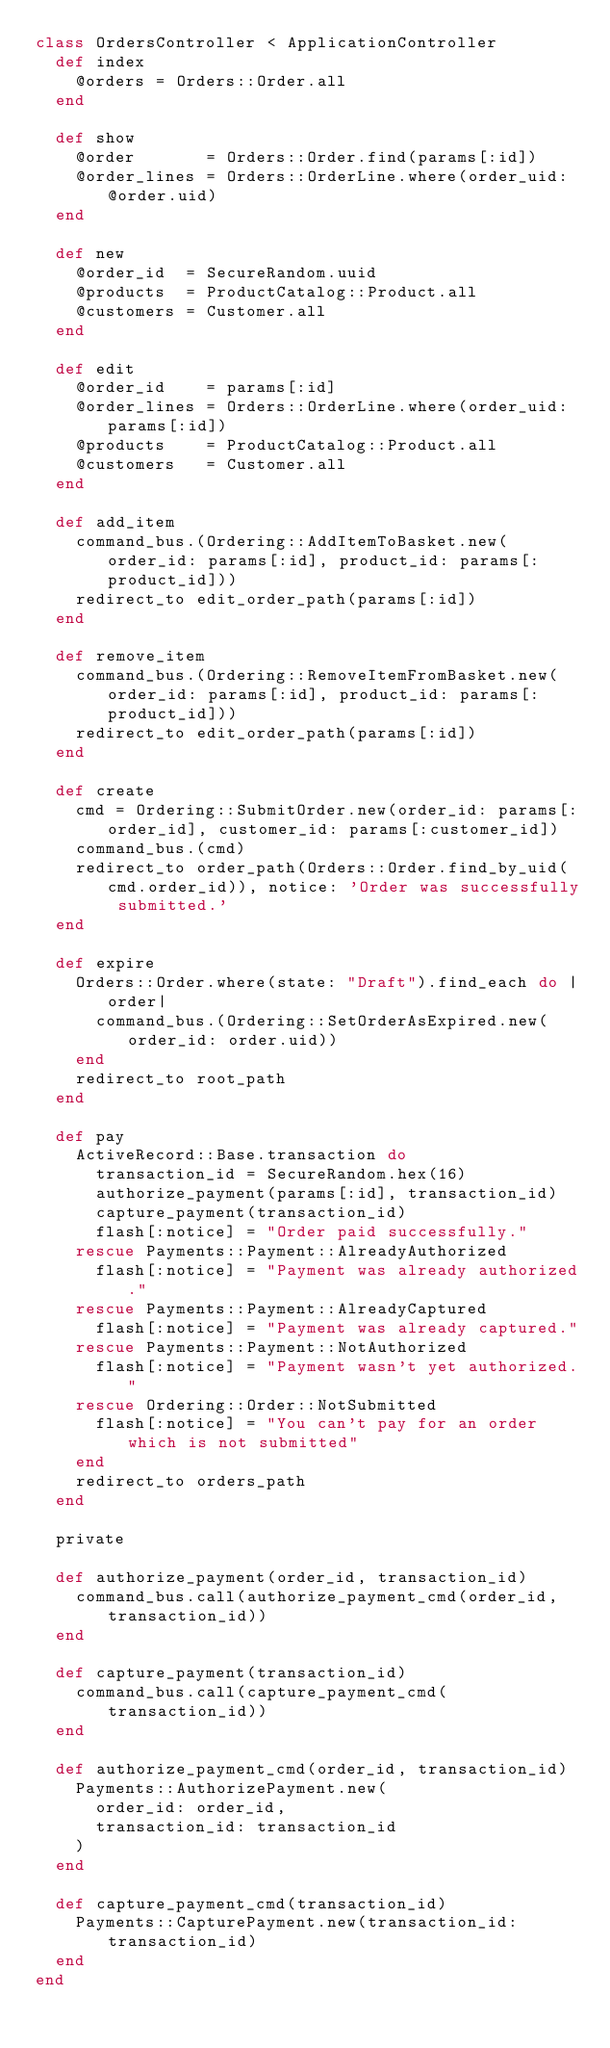<code> <loc_0><loc_0><loc_500><loc_500><_Ruby_>class OrdersController < ApplicationController
  def index
    @orders = Orders::Order.all
  end

  def show
    @order       = Orders::Order.find(params[:id])
    @order_lines = Orders::OrderLine.where(order_uid: @order.uid)
  end

  def new
    @order_id  = SecureRandom.uuid
    @products  = ProductCatalog::Product.all
    @customers = Customer.all
  end

  def edit
    @order_id    = params[:id]
    @order_lines = Orders::OrderLine.where(order_uid: params[:id])
    @products    = ProductCatalog::Product.all
    @customers   = Customer.all
  end

  def add_item
    command_bus.(Ordering::AddItemToBasket.new(order_id: params[:id], product_id: params[:product_id]))
    redirect_to edit_order_path(params[:id])
  end

  def remove_item
    command_bus.(Ordering::RemoveItemFromBasket.new(order_id: params[:id], product_id: params[:product_id]))
    redirect_to edit_order_path(params[:id])
  end

  def create
    cmd = Ordering::SubmitOrder.new(order_id: params[:order_id], customer_id: params[:customer_id])
    command_bus.(cmd)
    redirect_to order_path(Orders::Order.find_by_uid(cmd.order_id)), notice: 'Order was successfully submitted.'
  end

  def expire
    Orders::Order.where(state: "Draft").find_each do |order|
      command_bus.(Ordering::SetOrderAsExpired.new(order_id: order.uid))
    end
    redirect_to root_path
  end

  def pay
    ActiveRecord::Base.transaction do
      transaction_id = SecureRandom.hex(16)
      authorize_payment(params[:id], transaction_id)
      capture_payment(transaction_id)
      flash[:notice] = "Order paid successfully."
    rescue Payments::Payment::AlreadyAuthorized
      flash[:notice] = "Payment was already authorized."
    rescue Payments::Payment::AlreadyCaptured
      flash[:notice] = "Payment was already captured."
    rescue Payments::Payment::NotAuthorized
      flash[:notice] = "Payment wasn't yet authorized."
    rescue Ordering::Order::NotSubmitted
      flash[:notice] = "You can't pay for an order which is not submitted"
    end
    redirect_to orders_path
  end

  private

  def authorize_payment(order_id, transaction_id)
    command_bus.call(authorize_payment_cmd(order_id, transaction_id))
  end

  def capture_payment(transaction_id)
    command_bus.call(capture_payment_cmd(transaction_id))
  end

  def authorize_payment_cmd(order_id, transaction_id)
    Payments::AuthorizePayment.new(
      order_id: order_id,
      transaction_id: transaction_id
    )
  end

  def capture_payment_cmd(transaction_id)
    Payments::CapturePayment.new(transaction_id: transaction_id)
  end
end
</code> 